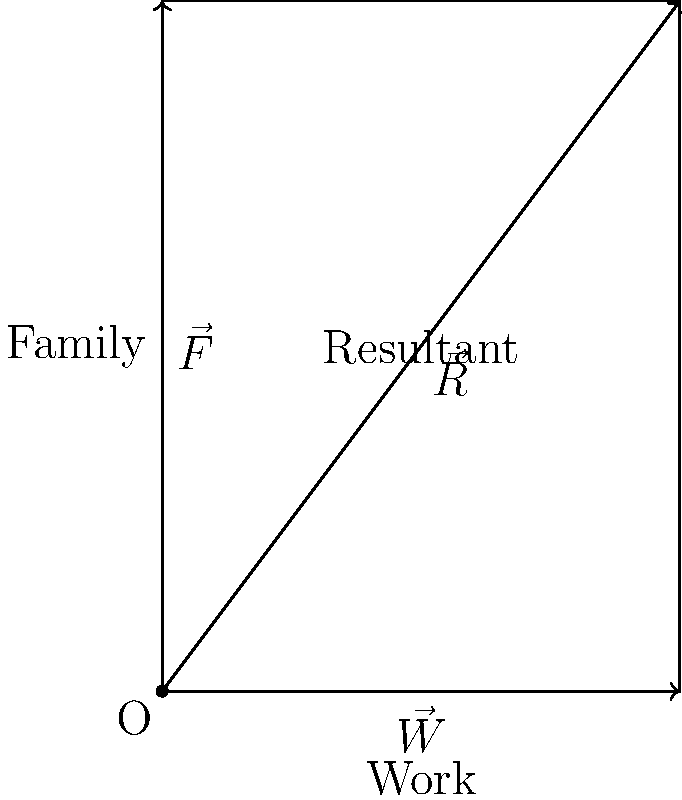As a single parent balancing work and family responsibilities, you can represent these competing forces using a vector diagram. In the given force diagram, $\vec{W}$ represents work responsibilities (magnitude 3), $\vec{F}$ represents family responsibilities (magnitude 4), and $\vec{R}$ is the resultant vector. What is the magnitude of the resultant vector $\vec{R}$, rounded to one decimal place? To find the magnitude of the resultant vector $\vec{R}$, we can use the Pythagorean theorem since the work and family vectors are perpendicular to each other. 

Step 1: Identify the magnitudes of the vectors
$|\vec{W}| = 3$ (work responsibilities)
$|\vec{F}| = 4$ (family responsibilities)

Step 2: Apply the Pythagorean theorem
$|\vec{R}|^2 = |\vec{W}|^2 + |\vec{F}|^2$

Step 3: Substitute the values
$|\vec{R}|^2 = 3^2 + 4^2$
$|\vec{R}|^2 = 9 + 16$
$|\vec{R}|^2 = 25$

Step 4: Take the square root of both sides
$|\vec{R}| = \sqrt{25} = 5$

Step 5: Round to one decimal place
$|\vec{R}| \approx 5.0$

Therefore, the magnitude of the resultant vector $\vec{R}$ is 5.0.
Answer: 5.0 